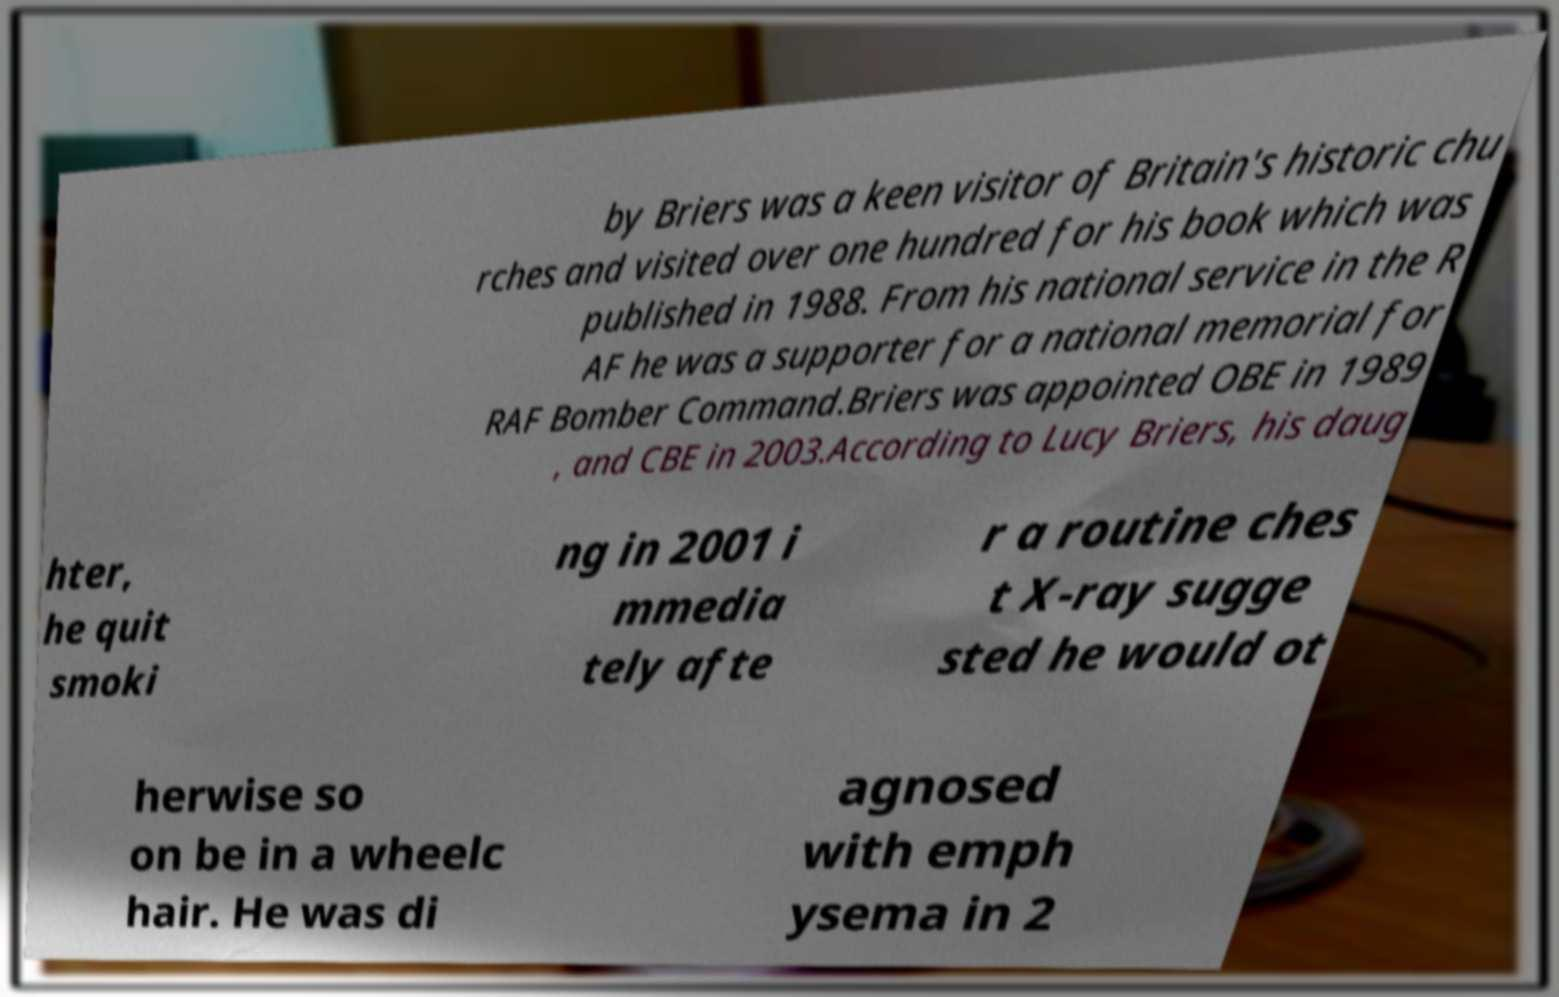Could you assist in decoding the text presented in this image and type it out clearly? by Briers was a keen visitor of Britain's historic chu rches and visited over one hundred for his book which was published in 1988. From his national service in the R AF he was a supporter for a national memorial for RAF Bomber Command.Briers was appointed OBE in 1989 , and CBE in 2003.According to Lucy Briers, his daug hter, he quit smoki ng in 2001 i mmedia tely afte r a routine ches t X-ray sugge sted he would ot herwise so on be in a wheelc hair. He was di agnosed with emph ysema in 2 